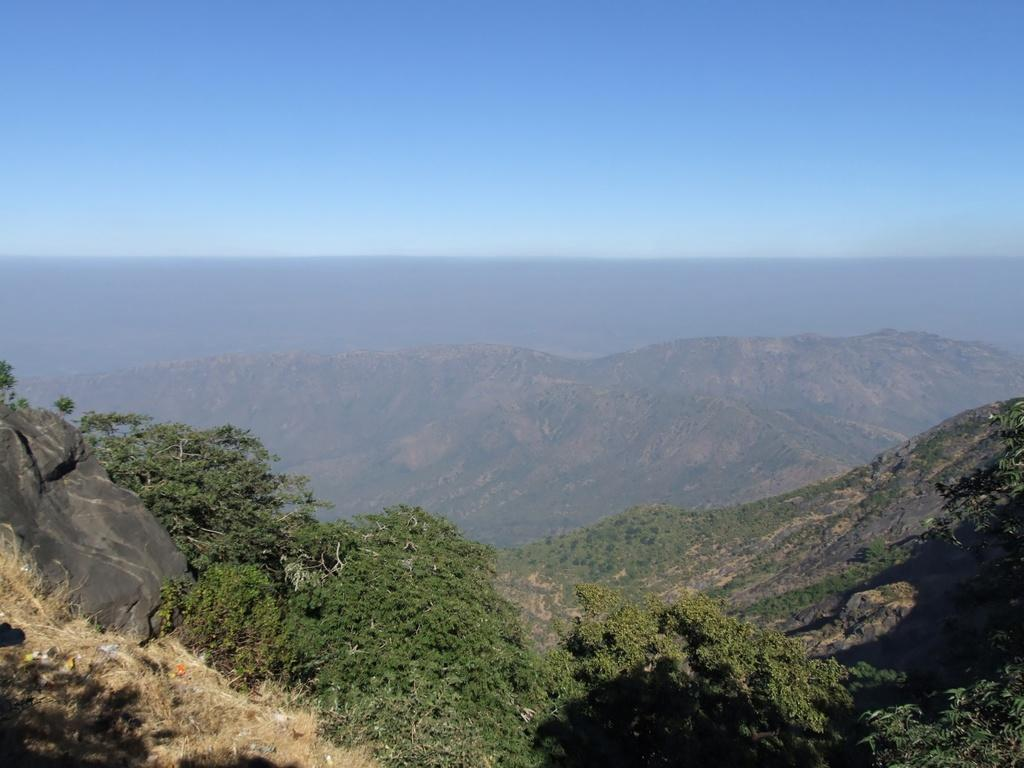What type of vegetation can be seen in the image? There are trees in the image. What geographical feature is located in the middle of the image? There are hills in the middle of the image. What is visible at the top of the image? The sky is visible at the top of the image. Who is the manager of the sky in the image? There is no manager of the sky in the image, as the sky is a natural phenomenon and not managed by any individual. 